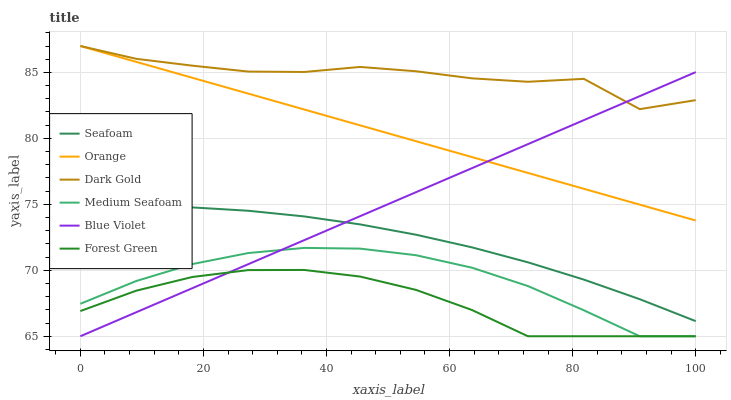Does Seafoam have the minimum area under the curve?
Answer yes or no. No. Does Seafoam have the maximum area under the curve?
Answer yes or no. No. Is Seafoam the smoothest?
Answer yes or no. No. Is Seafoam the roughest?
Answer yes or no. No. Does Seafoam have the lowest value?
Answer yes or no. No. Does Seafoam have the highest value?
Answer yes or no. No. Is Medium Seafoam less than Dark Gold?
Answer yes or no. Yes. Is Dark Gold greater than Medium Seafoam?
Answer yes or no. Yes. Does Medium Seafoam intersect Dark Gold?
Answer yes or no. No. 